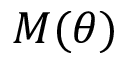<formula> <loc_0><loc_0><loc_500><loc_500>M ( \theta )</formula> 